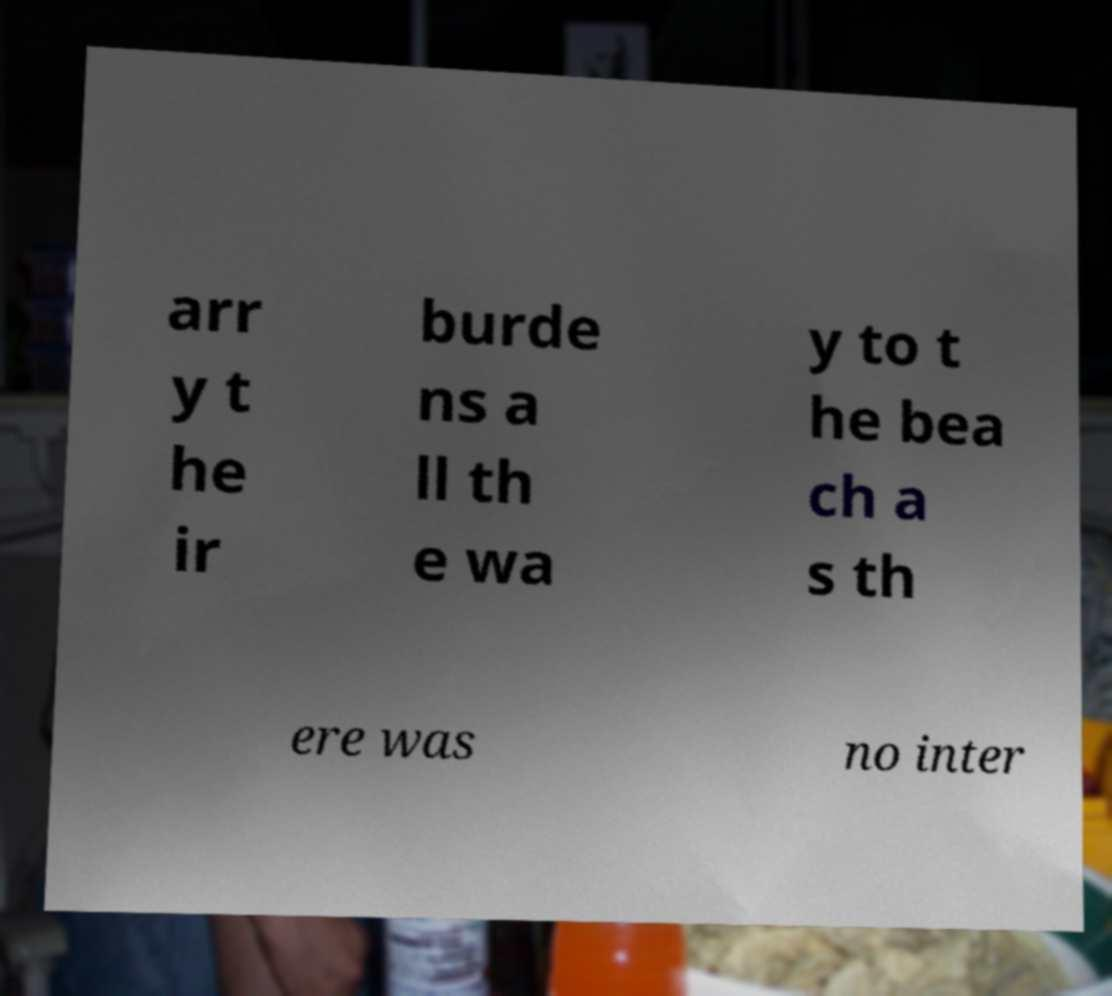Could you extract and type out the text from this image? arr y t he ir burde ns a ll th e wa y to t he bea ch a s th ere was no inter 